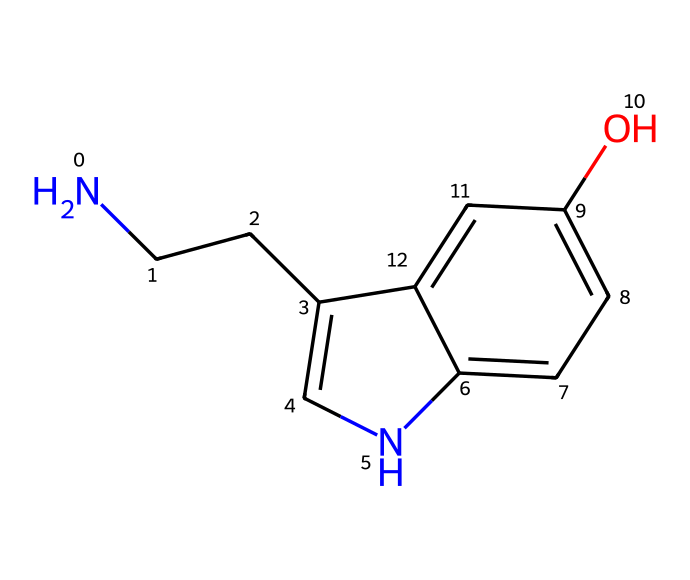What is the molecular formula of the compound represented by the SMILES? To deduce the molecular formula from the SMILES representation, count the number of different atoms present. Here, we identify 10 carbon atoms, 12 hydrogen atoms, 2 nitrogen atoms, and 1 oxygen atom. Therefore, the molecular formula is C10H12N2O.
Answer: C10H12N2O How many rings are present in this structure? Inspecting the SMILES, we can observe two ring systems formed by the connections in the aromatic structure, specifically involving the 'c' letters in the notation. Thus, there are two rings in the structure.
Answer: 2 What functional group is present in the compound? In the SMILES, the letter 'O' denotes an oxygen atom that is part of a hydroxyl (-OH) functional group. This is often associated with alcohols, indicating that the compound contains a hydroxyl group.
Answer: hydroxyl What is the role of the nitrogen atoms in this alkaloid? The nitrogen atoms in this alkaloid mainly serve as sites for basicity and contribute to the psychoactive properties of alkaloids, such as their involvement in neurotransmission, particularly in mood regulation mediated by serotonin pathways.
Answer: neurotransmission Does this structure suggest a relationship with mood regulation? Yes, the presence of nitrogen atoms often links alkaloids to neurotransmitter activity, and since this compound can affect serotonin levels, it suggests its potential role in influencing mood and emotional states.
Answer: yes 